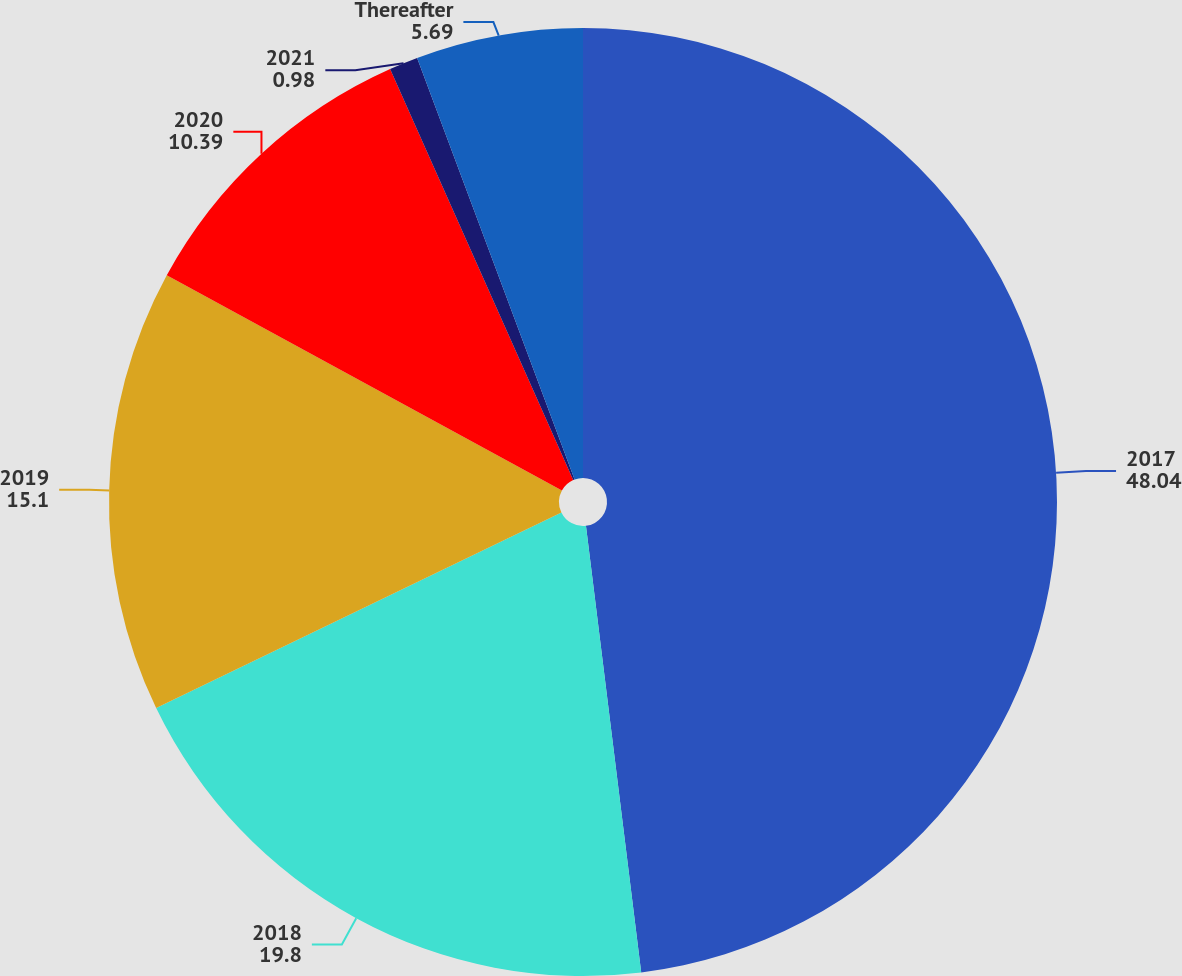<chart> <loc_0><loc_0><loc_500><loc_500><pie_chart><fcel>2017<fcel>2018<fcel>2019<fcel>2020<fcel>2021<fcel>Thereafter<nl><fcel>48.04%<fcel>19.8%<fcel>15.1%<fcel>10.39%<fcel>0.98%<fcel>5.69%<nl></chart> 